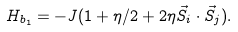Convert formula to latex. <formula><loc_0><loc_0><loc_500><loc_500>H _ { b _ { 1 } } = - J ( 1 + \eta / 2 + 2 \eta \vec { S } _ { i } \cdot \vec { S } _ { j } ) .</formula> 